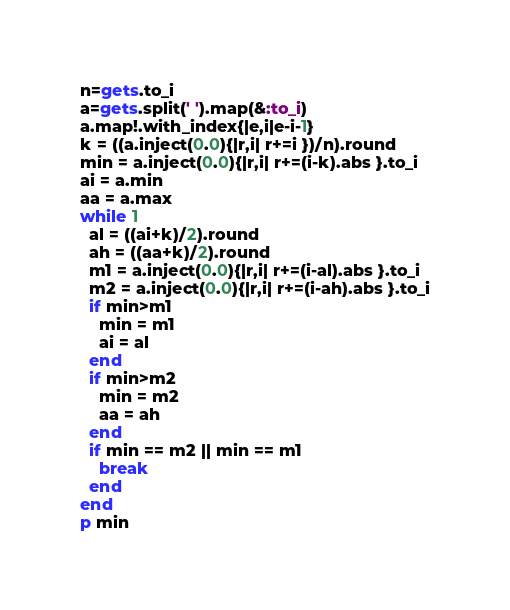<code> <loc_0><loc_0><loc_500><loc_500><_Ruby_>n=gets.to_i
a=gets.split(' ').map(&:to_i)
a.map!.with_index{|e,i|e-i-1}
k = ((a.inject(0.0){|r,i| r+=i })/n).round
min = a.inject(0.0){|r,i| r+=(i-k).abs }.to_i
ai = a.min
aa = a.max
while 1
  al = ((ai+k)/2).round
  ah = ((aa+k)/2).round
  m1 = a.inject(0.0){|r,i| r+=(i-al).abs }.to_i
  m2 = a.inject(0.0){|r,i| r+=(i-ah).abs }.to_i
  if min>m1
    min = m1
    ai = al
  end
  if min>m2
    min = m2
    aa = ah
  end
  if min == m2 || min == m1
    break
  end
end
p min
</code> 